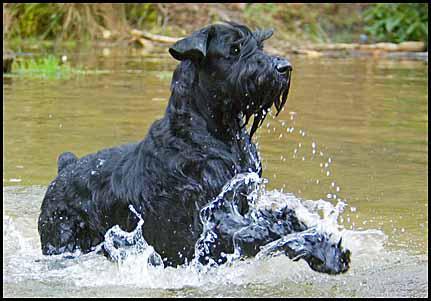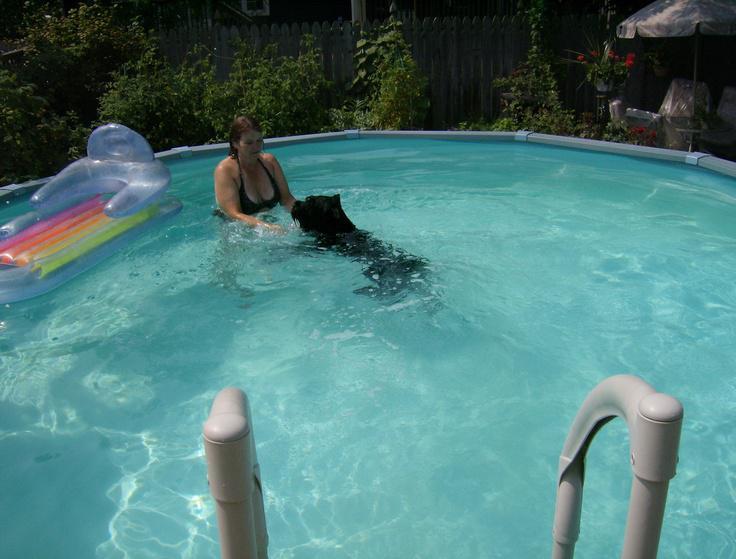The first image is the image on the left, the second image is the image on the right. Evaluate the accuracy of this statement regarding the images: "Exactly one dog is partly in the water.". Is it true? Answer yes or no. No. The first image is the image on the left, the second image is the image on the right. Given the left and right images, does the statement "two dogs are on the side of the pool looking at the water" hold true? Answer yes or no. No. 